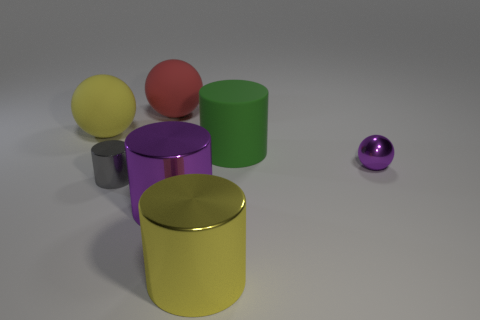How does the size of the purple metallic ball compare to the other objects in the scene? The purple metallic ball is smaller than the cylinders and is roughly the same size as the yellow and red balls, which appear to be a standard size for small rubber balls. It's placed to the far right and is separate from the group of other objects. What might be the significance of the arrangement of these objects? The arrangement may not hold any specific significance; it resembles a still life setup, possibly designed for an exercise in lighting, shading, and perspective. The various colors and finishes, including matte and metallic, allow viewers to see how light interacts with different surfaces and colors. 